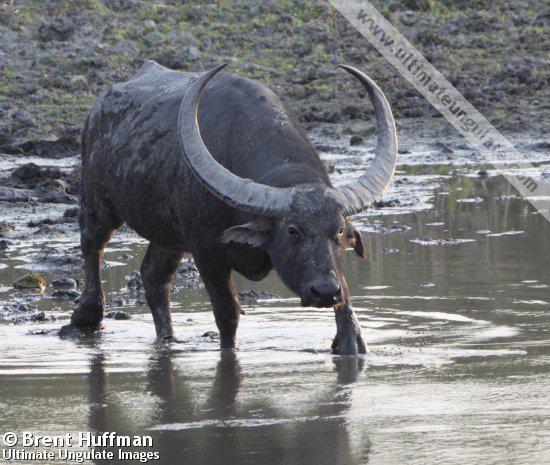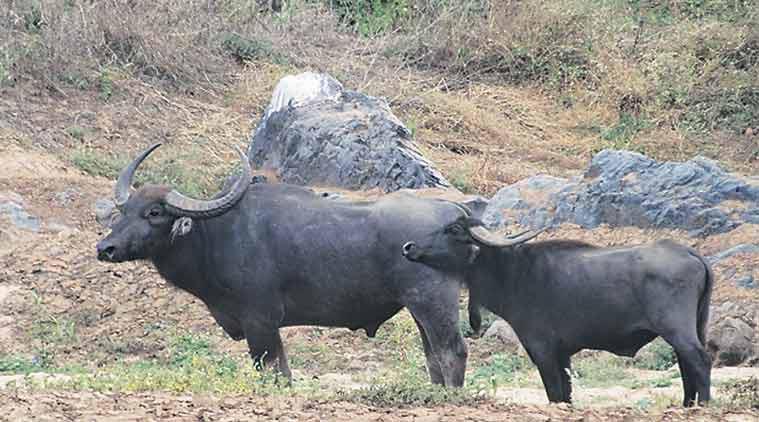The first image is the image on the left, the second image is the image on the right. Evaluate the accuracy of this statement regarding the images: "The animals in the image on the left are near an area of water.". Is it true? Answer yes or no. Yes. The first image is the image on the left, the second image is the image on the right. For the images shown, is this caption "An image shows exactly two water buffalo standing in profile." true? Answer yes or no. Yes. 